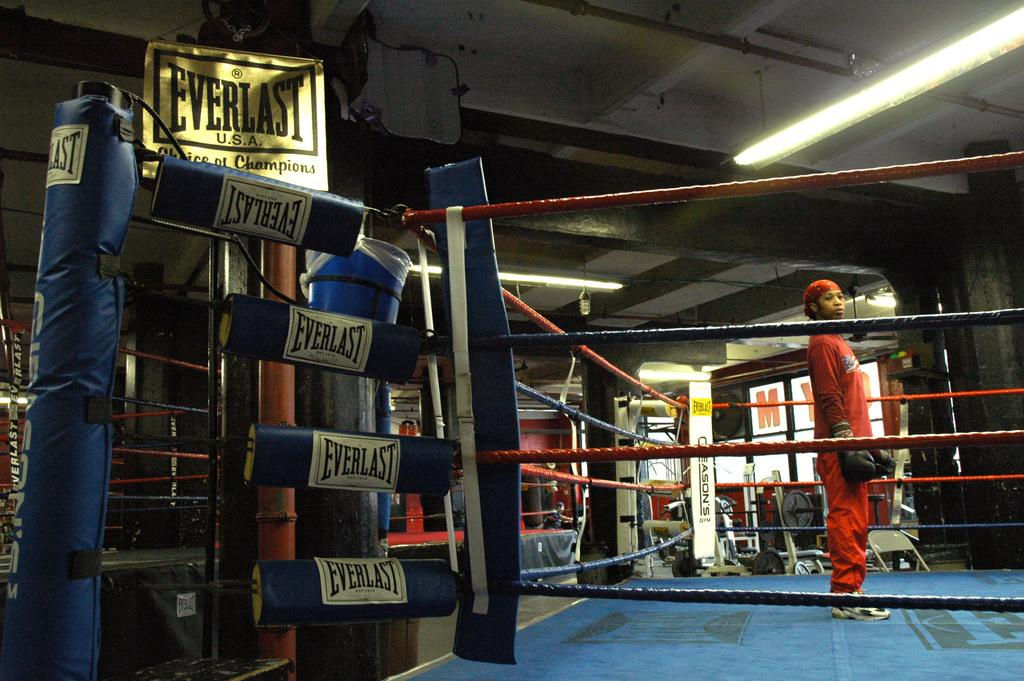<image>
Summarize the visual content of the image. The boxing ring has pads that read Everlast on them. 